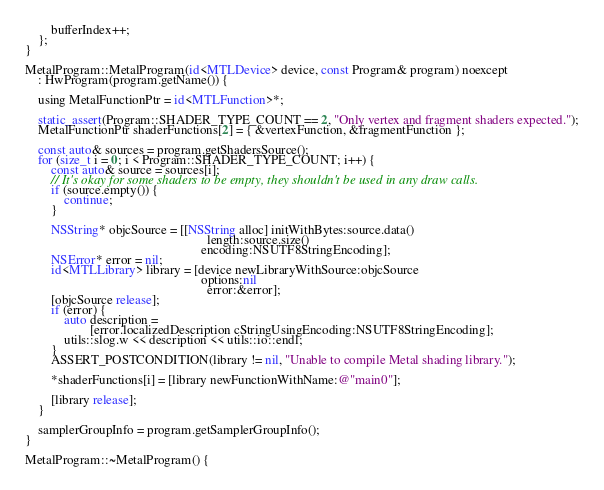Convert code to text. <code><loc_0><loc_0><loc_500><loc_500><_ObjectiveC_>
        bufferIndex++;
    };
}

MetalProgram::MetalProgram(id<MTLDevice> device, const Program& program) noexcept
    : HwProgram(program.getName()) {

    using MetalFunctionPtr = id<MTLFunction>*;

    static_assert(Program::SHADER_TYPE_COUNT == 2, "Only vertex and fragment shaders expected.");
    MetalFunctionPtr shaderFunctions[2] = { &vertexFunction, &fragmentFunction };

    const auto& sources = program.getShadersSource();
    for (size_t i = 0; i < Program::SHADER_TYPE_COUNT; i++) {
        const auto& source = sources[i];
        // It's okay for some shaders to be empty, they shouldn't be used in any draw calls.
        if (source.empty()) {
            continue;
        }

        NSString* objcSource = [[NSString alloc] initWithBytes:source.data()
                                                        length:source.size()
                                                      encoding:NSUTF8StringEncoding];
        NSError* error = nil;
        id<MTLLibrary> library = [device newLibraryWithSource:objcSource
                                                      options:nil
                                                        error:&error];
        [objcSource release];
        if (error) {
            auto description =
                    [error.localizedDescription cStringUsingEncoding:NSUTF8StringEncoding];
            utils::slog.w << description << utils::io::endl;
        }
        ASSERT_POSTCONDITION(library != nil, "Unable to compile Metal shading library.");

        *shaderFunctions[i] = [library newFunctionWithName:@"main0"];

        [library release];
    }

    samplerGroupInfo = program.getSamplerGroupInfo();
}

MetalProgram::~MetalProgram() {</code> 